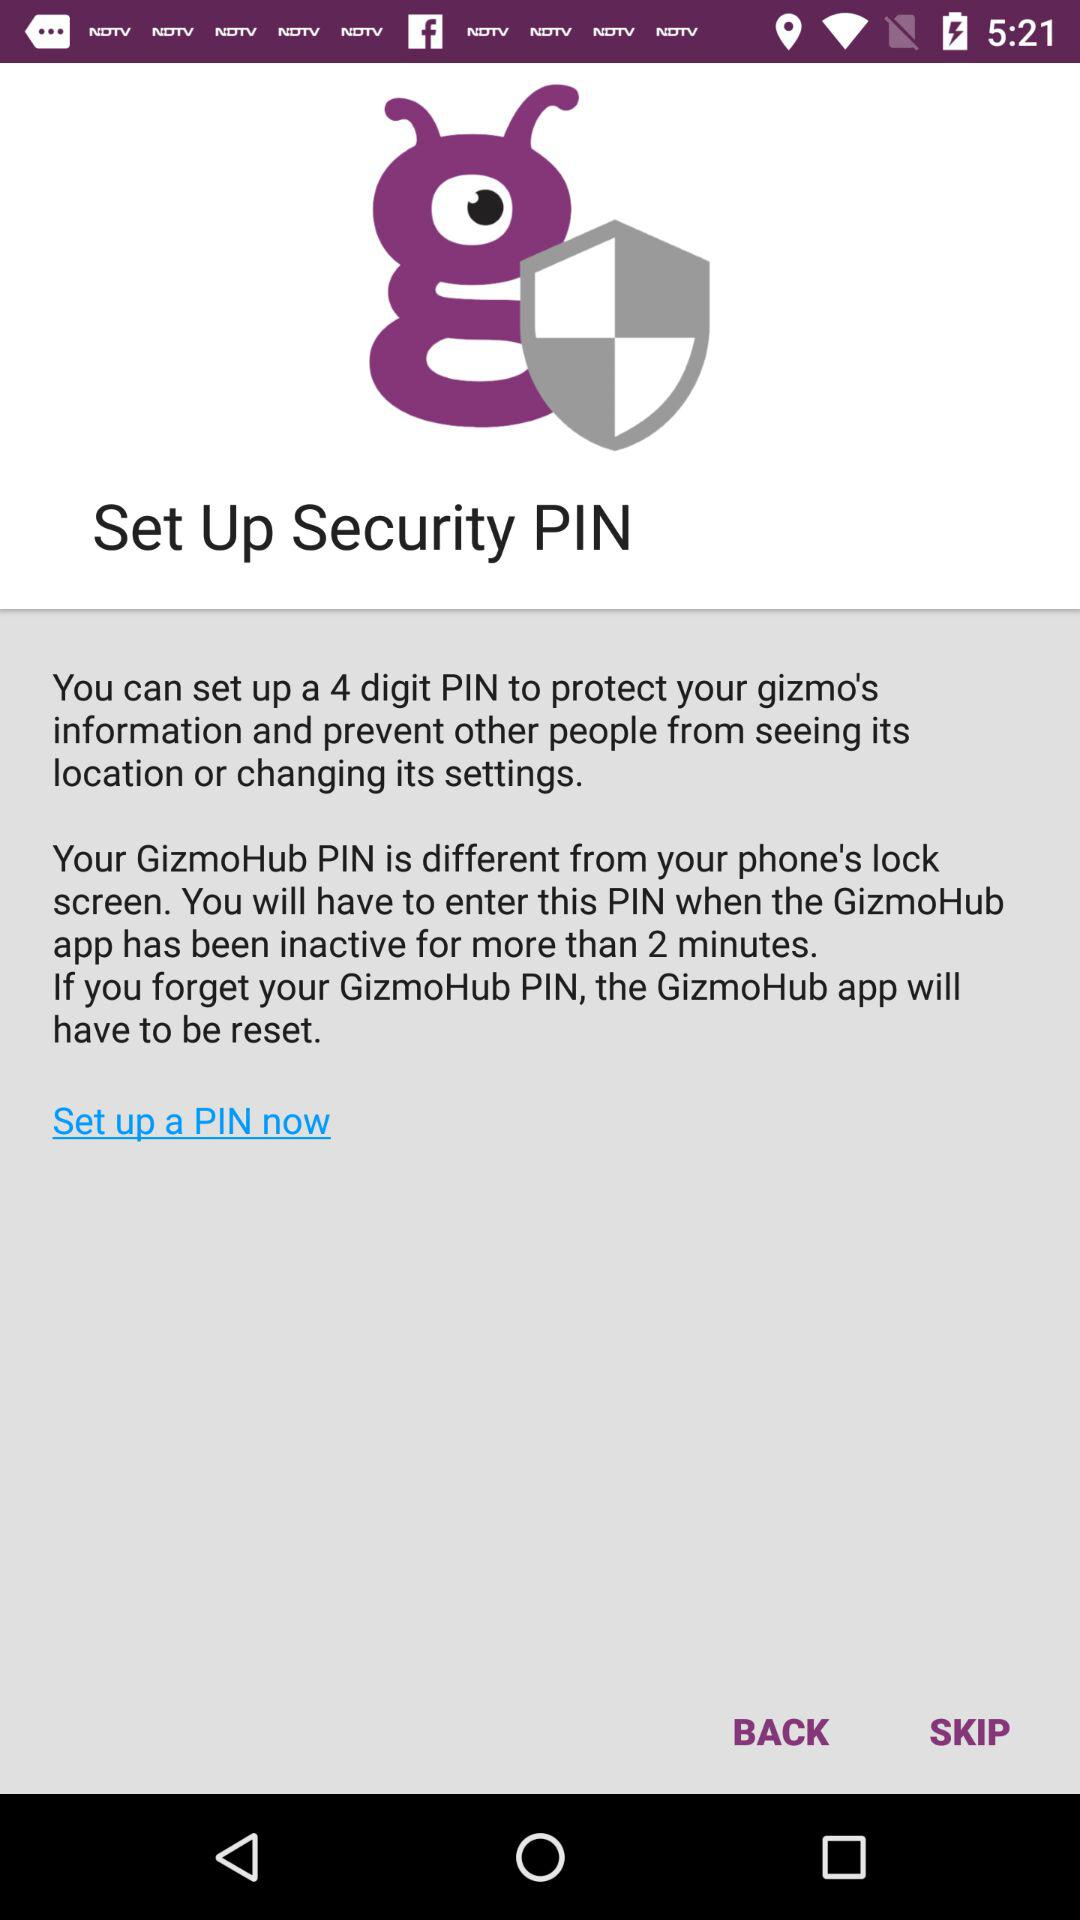How many different PINs do I need to know?
Answer the question using a single word or phrase. 2 